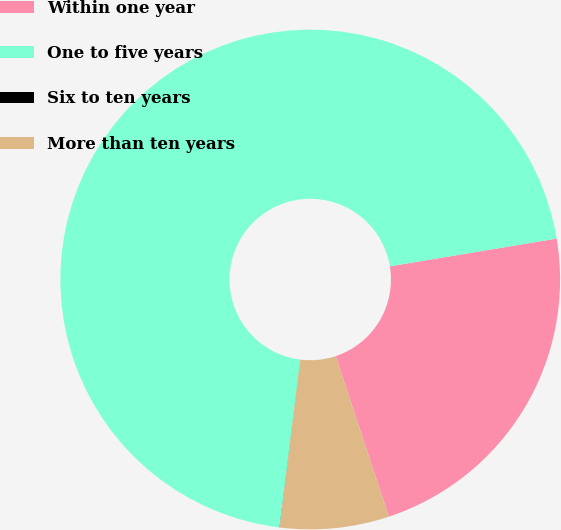<chart> <loc_0><loc_0><loc_500><loc_500><pie_chart><fcel>Within one year<fcel>One to five years<fcel>Six to ten years<fcel>More than ten years<nl><fcel>22.52%<fcel>70.42%<fcel>0.01%<fcel>7.05%<nl></chart> 